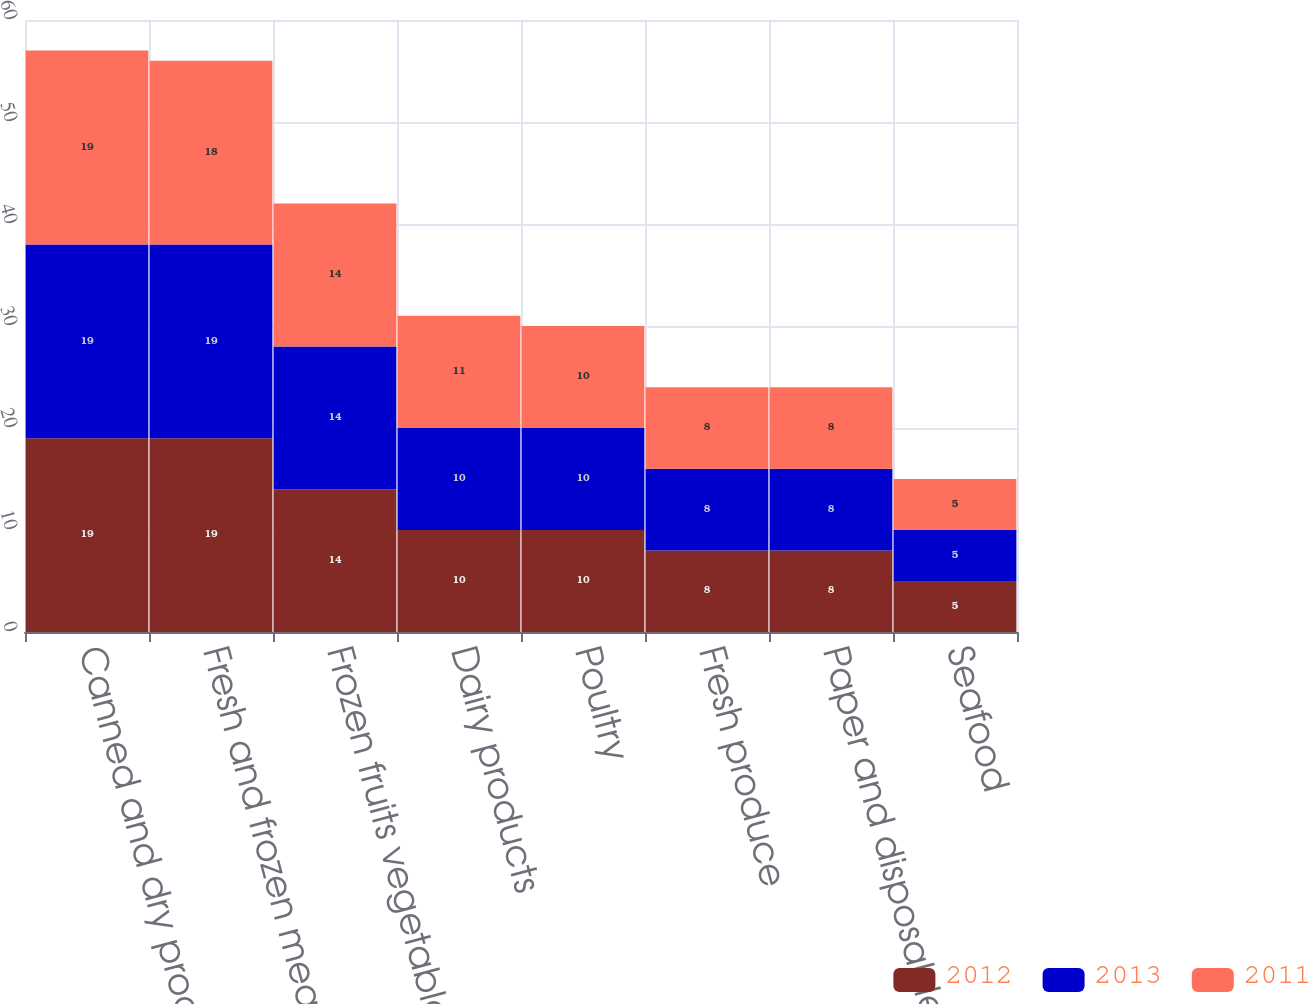Convert chart to OTSL. <chart><loc_0><loc_0><loc_500><loc_500><stacked_bar_chart><ecel><fcel>Canned and dry products<fcel>Fresh and frozen meats<fcel>Frozen fruits vegetables<fcel>Dairy products<fcel>Poultry<fcel>Fresh produce<fcel>Paper and disposables<fcel>Seafood<nl><fcel>2012<fcel>19<fcel>19<fcel>14<fcel>10<fcel>10<fcel>8<fcel>8<fcel>5<nl><fcel>2013<fcel>19<fcel>19<fcel>14<fcel>10<fcel>10<fcel>8<fcel>8<fcel>5<nl><fcel>2011<fcel>19<fcel>18<fcel>14<fcel>11<fcel>10<fcel>8<fcel>8<fcel>5<nl></chart> 